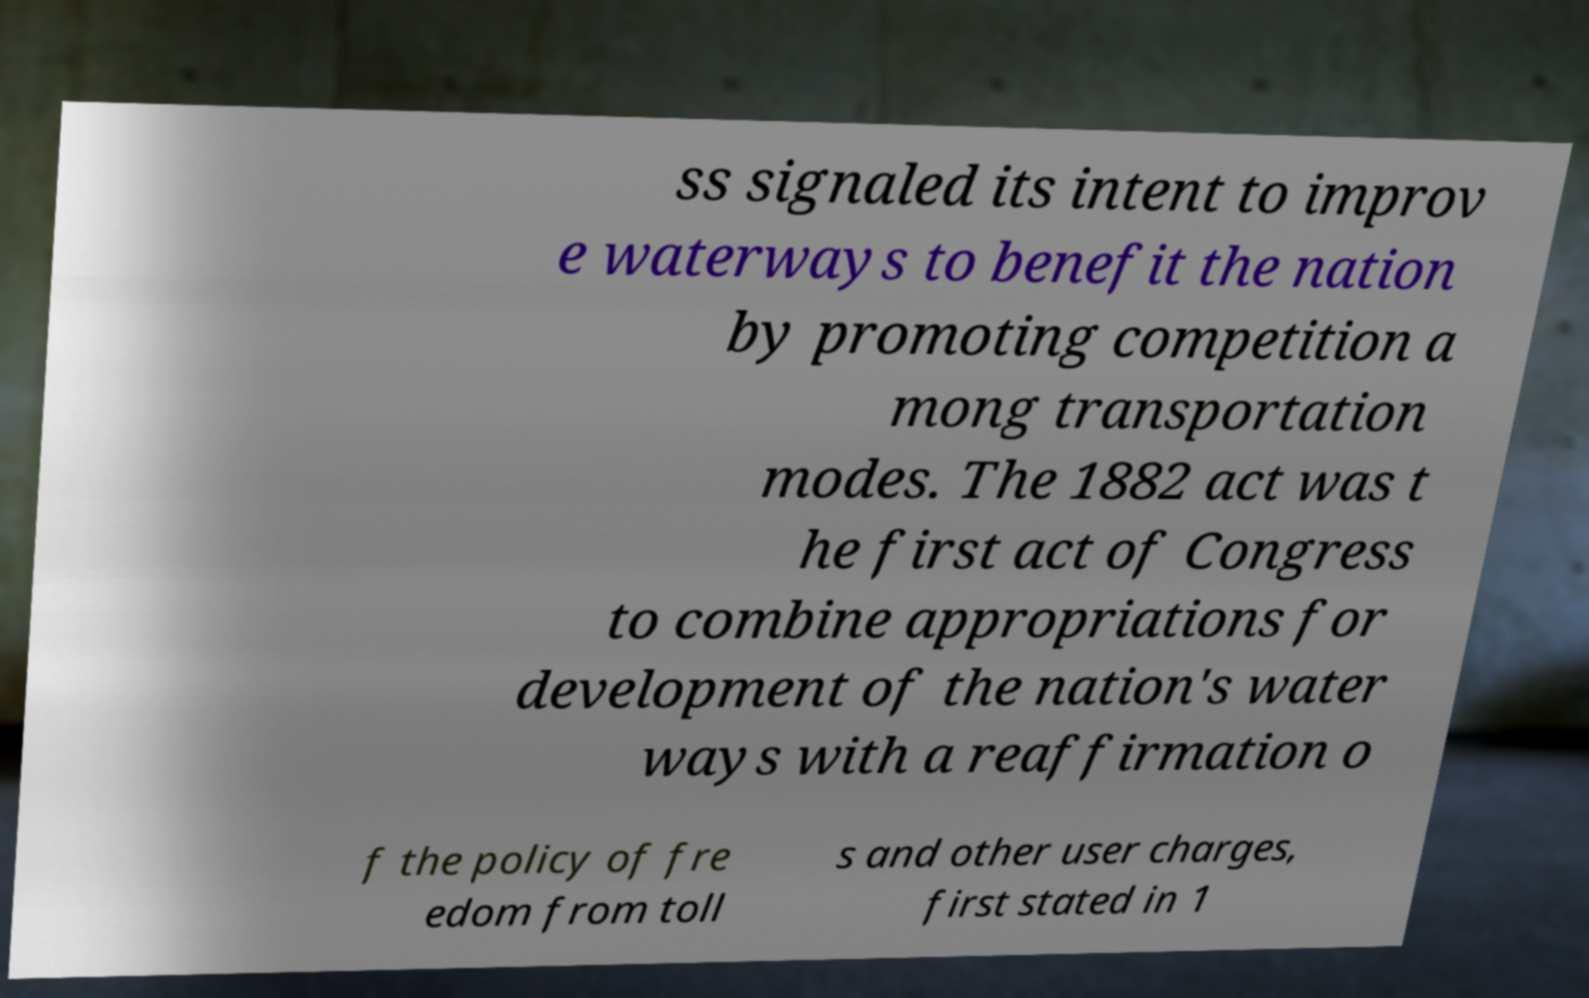Can you accurately transcribe the text from the provided image for me? ss signaled its intent to improv e waterways to benefit the nation by promoting competition a mong transportation modes. The 1882 act was t he first act of Congress to combine appropriations for development of the nation's water ways with a reaffirmation o f the policy of fre edom from toll s and other user charges, first stated in 1 